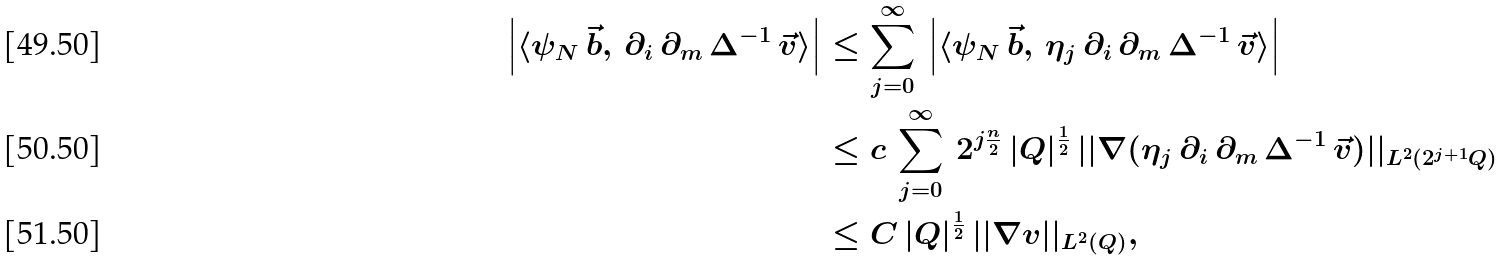<formula> <loc_0><loc_0><loc_500><loc_500>\left | \langle \psi _ { N } \, \vec { b } , \, \partial _ { i } \, \partial _ { m } \, \Delta ^ { - 1 } \, \vec { v } \rangle \right | & \leq \sum _ { j = 0 } ^ { \infty } \, \left | \langle \psi _ { N } \, \vec { b } , \, \eta _ { j } \, \partial _ { i } \, \partial _ { m } \, \Delta ^ { - 1 } \, \vec { v } \rangle \right | \\ & \leq c \, \sum _ { j = 0 } ^ { \infty } \, 2 ^ { j \frac { n } { 2 } } \, | Q | ^ { \frac { 1 } { 2 } } \, | | \nabla ( \eta _ { j } \, \partial _ { i } \, \partial _ { m } \, \Delta ^ { - 1 } \, \vec { v } ) | | _ { L ^ { 2 } ( 2 ^ { j + 1 } Q ) } \\ & \leq C \, | Q | ^ { \frac { 1 } { 2 } } \, | | \nabla v | | _ { L ^ { 2 } ( Q ) } ,</formula> 